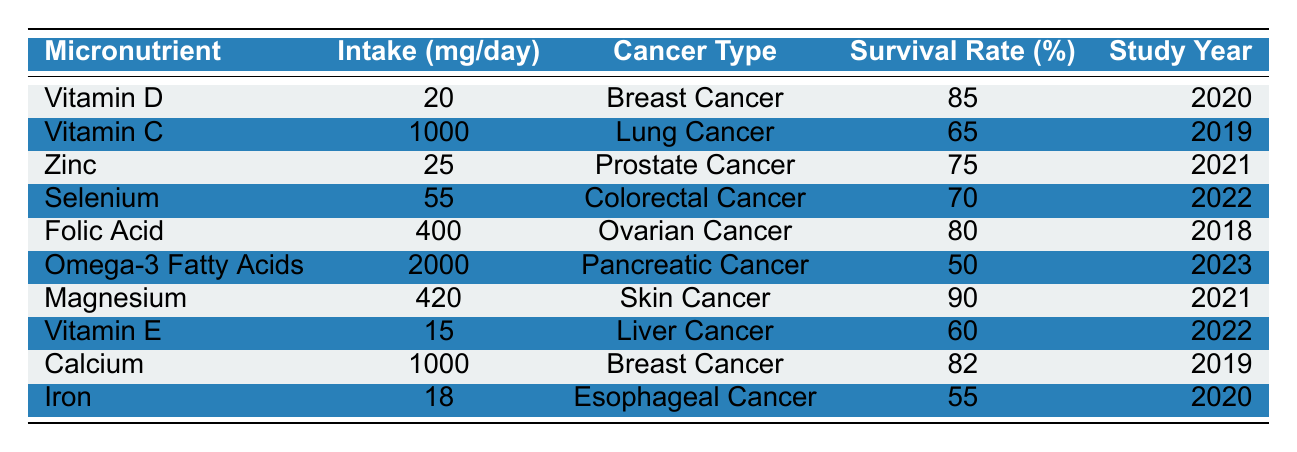What is the survival rate for Lung Cancer patients taking Vitamin C? The table lists Vitamin C under Lung Cancer with a survival rate of 65%.
Answer: 65% Which micronutrient has the highest reported survival rate? The table shows Magnesium with a survival rate of 90%, which is the highest among all listed micronutrients.
Answer: 90% Is the intake level of Omega-3 Fatty Acids higher than that of Zinc? Omega-3 Fatty Acids have an intake level of 2000 mg/day, while Zinc has 25 mg/day, so Omega-3's intake level is higher.
Answer: Yes What is the average survival rate for Breast Cancer patients listed in the table? The survival rates for Breast Cancer from the table are 85% (Vitamin D) and 82% (Calcium). The average is (85 + 82) / 2 = 83.5%.
Answer: 83.5% What is the difference in survival rates between Prostate Cancer and Skin Cancer? Prostate Cancer has a survival rate of 75% (Zinc) and Skin Cancer has 90% (Magnesium). The difference is 90 - 75 = 15%.
Answer: 15% Has the survival rate for Colorectal Cancer patients increased compared to those with Pancreatic Cancer? Colorectal Cancer has a survival rate of 70% (Selenium) while Pancreatic Cancer has a survival rate of 50% (Omega-3 Fatty Acids), indicating an increase.
Answer: Yes Which study year had the highest intake of magnesium, and what was the survival rate for that cancer type? Magnesium was taken at 420 mg/day for Skin Cancer in 2021, with a survival rate of 90%.
Answer: 90% in 2021 What is the total intake of Calcium and Iron in mg/day for cancer patients listed? Calcium has an intake of 1000 mg/day and Iron has 18 mg/day. The total is 1000 + 18 = 1018 mg/day.
Answer: 1018 mg/day Is the survival rate of patients taking Selenium equal to the survival rate of those taking Vitamin E? Selenium has a survival rate of 70% while Vitamin E has 60%, which means they are not equal.
Answer: No List the micronutrient with the lowest survival rate and its corresponding cancer type. The table shows Omega-3 Fatty Acids with a survival rate of 50% for Pancreatic Cancer, which is the lowest.
Answer: Omega-3 Fatty Acids for Pancreatic Cancer at 50% 